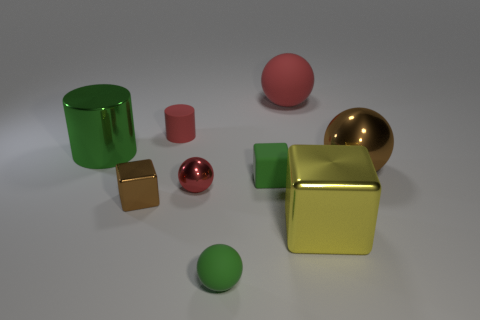Does the metal ball left of the big brown shiny object have the same color as the tiny rubber cylinder?
Offer a terse response. Yes. There is a red rubber object on the right side of the small red sphere; what is its size?
Make the answer very short. Large. Does the matte cube have the same color as the large metallic cylinder?
Ensure brevity in your answer.  Yes. How many large objects are purple rubber things or red metallic spheres?
Provide a succinct answer. 0. Are there any other things that have the same color as the big shiny cylinder?
Provide a short and direct response. Yes. There is a big green thing; are there any big blocks to the left of it?
Your response must be concise. No. What size is the red sphere behind the green thing behind the large brown ball?
Give a very brief answer. Large. Are there an equal number of large yellow metallic blocks on the right side of the big yellow thing and small red rubber things that are behind the large green shiny cylinder?
Your answer should be very brief. No. Is there a large metal block that is in front of the small green sphere in front of the rubber cylinder?
Your answer should be very brief. No. There is a rubber ball behind the sphere that is in front of the yellow block; what number of small rubber balls are to the left of it?
Your answer should be very brief. 1. 